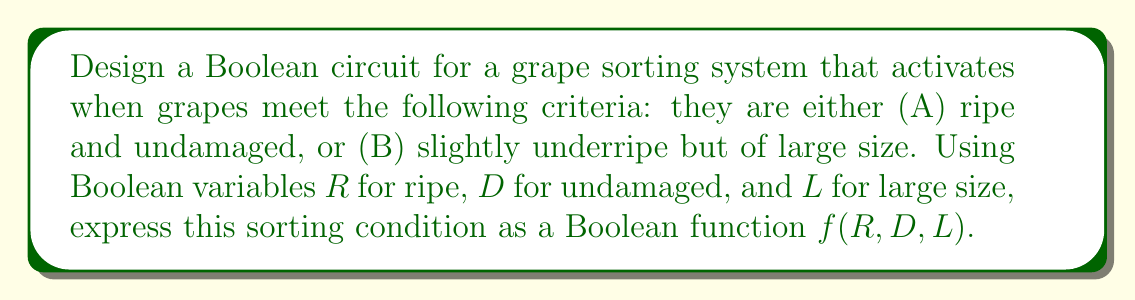Show me your answer to this math problem. Let's approach this step-by-step:

1) First, let's define our Boolean variables:
   R: Ripe (1 if ripe, 0 if not)
   D: Undamaged (1 if undamaged, 0 if damaged)
   L: Large size (1 if large, 0 if not)

2) Now, let's break down the conditions:
   Condition A: Ripe AND Undamaged
   This can be expressed as: $R \cdot D$

   Condition B: Slightly underripe (NOT Ripe) AND Large size
   This can be expressed as: $\overline{R} \cdot L$

3) The system should activate if either Condition A OR Condition B is true.
   In Boolean algebra, OR is represented by the + symbol.

4) Therefore, our Boolean function can be written as:
   $f(R,D,L) = (R \cdot D) + (\overline{R} \cdot L)$

5) This can be read as: "The function is true (1) if either (Ripe AND Undamaged) OR (NOT Ripe AND Large) is true."

6) In terms of a circuit, this would involve AND gates for $(R \cdot D)$ and $(\overline{R} \cdot L)$, a NOT gate for $\overline{R}$, and an OR gate to combine the results of the two AND operations.
Answer: $f(R,D,L) = (R \cdot D) + (\overline{R} \cdot L)$ 